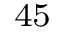Convert formula to latex. <formula><loc_0><loc_0><loc_500><loc_500>^ { 4 5 }</formula> 